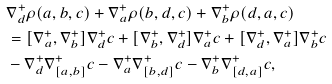<formula> <loc_0><loc_0><loc_500><loc_500>& \nabla _ { d } ^ { + } \rho ( a , b , c ) + \nabla _ { a } ^ { + } \rho ( b , d , c ) + \nabla _ { b } ^ { + } \rho ( d , a , c ) \\ & = [ \nabla _ { a } ^ { + } , \nabla _ { b } ^ { + } ] \nabla _ { d } ^ { + } c + [ \nabla _ { b } ^ { + } , \nabla _ { d } ^ { + } ] \nabla _ { a } ^ { + } c + [ \nabla _ { d } ^ { + } , \nabla _ { a } ^ { + } ] \nabla _ { b } ^ { + } c \\ & - \nabla _ { d } ^ { + } \nabla _ { [ a , b ] } ^ { + } c - \nabla _ { a } ^ { + } \nabla _ { [ b , d ] } ^ { + } c - \nabla _ { b } ^ { + } \nabla _ { [ d , a ] } ^ { + } c ,</formula> 